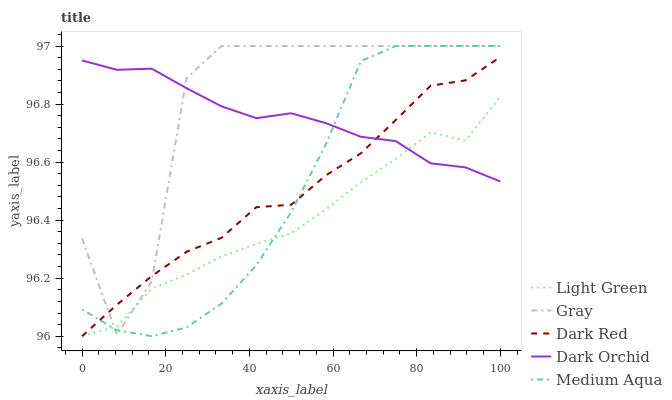Does Light Green have the minimum area under the curve?
Answer yes or no. Yes. Does Gray have the maximum area under the curve?
Answer yes or no. Yes. Does Medium Aqua have the minimum area under the curve?
Answer yes or no. No. Does Medium Aqua have the maximum area under the curve?
Answer yes or no. No. Is Dark Orchid the smoothest?
Answer yes or no. Yes. Is Gray the roughest?
Answer yes or no. Yes. Is Medium Aqua the smoothest?
Answer yes or no. No. Is Medium Aqua the roughest?
Answer yes or no. No. Does Dark Red have the lowest value?
Answer yes or no. Yes. Does Medium Aqua have the lowest value?
Answer yes or no. No. Does Medium Aqua have the highest value?
Answer yes or no. Yes. Does Dark Orchid have the highest value?
Answer yes or no. No. Does Gray intersect Dark Red?
Answer yes or no. Yes. Is Gray less than Dark Red?
Answer yes or no. No. Is Gray greater than Dark Red?
Answer yes or no. No. 